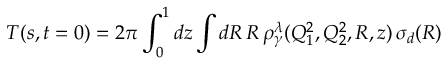Convert formula to latex. <formula><loc_0><loc_0><loc_500><loc_500>T ( s , t = 0 ) = 2 \pi \int _ { 0 } ^ { 1 } d z \int d R \, R \, \rho _ { \gamma } ^ { \lambda } ( Q _ { 1 } ^ { 2 } , Q _ { 2 } ^ { 2 } , R , z ) \, \sigma _ { d } ( R )</formula> 